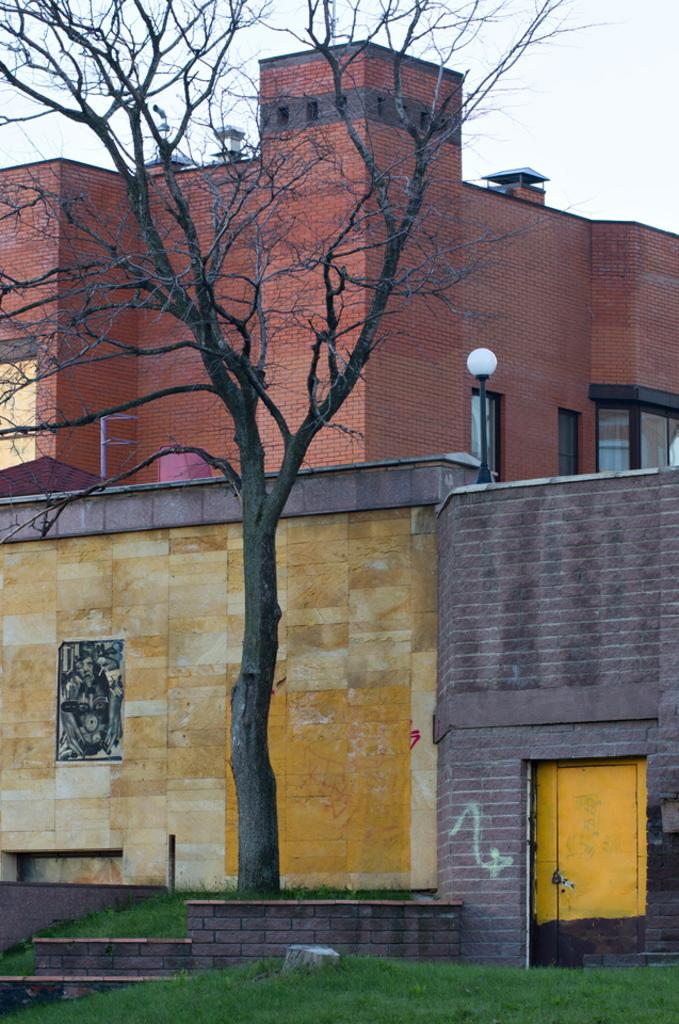What type of tree is in the image? There is a dried tree in the image. What other structures can be seen in the background of the image? There is a light pole and multi-colored buildings in the background of the image. What is the color of the sky in the image? The sky appears to be white in color in the image. What type of juice is being squeezed from the wrist in the image? There is no wrist or juice present in the image. 